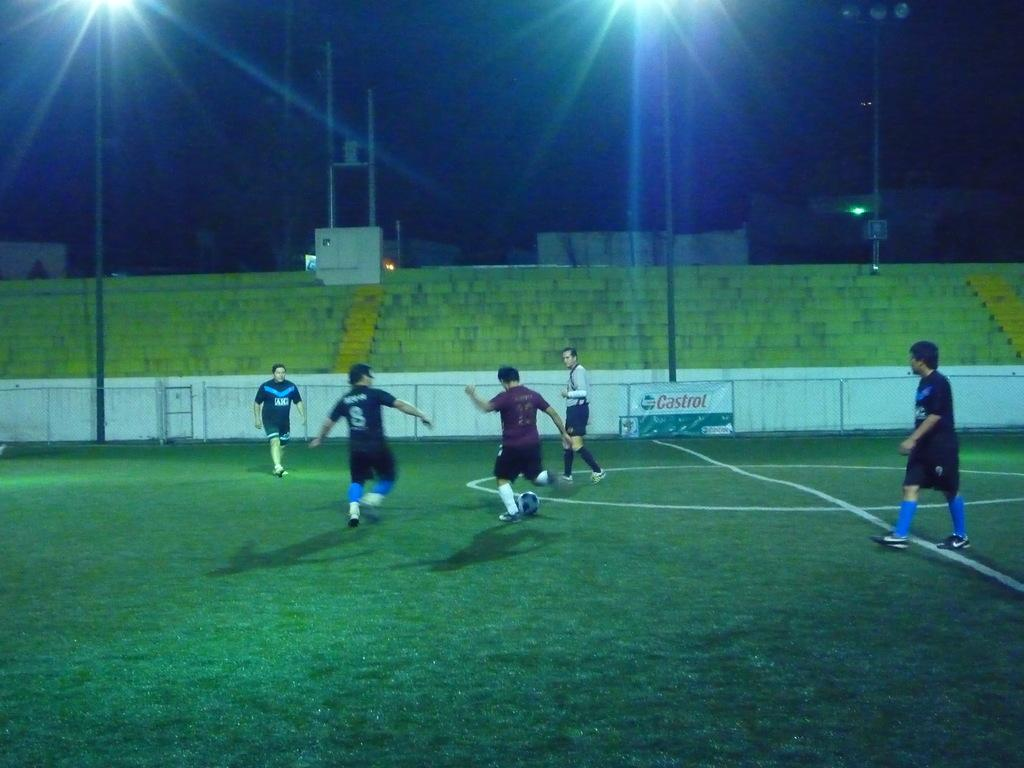<image>
Describe the image concisely. multiple soccer players playing on a field in front of a castrol sign 